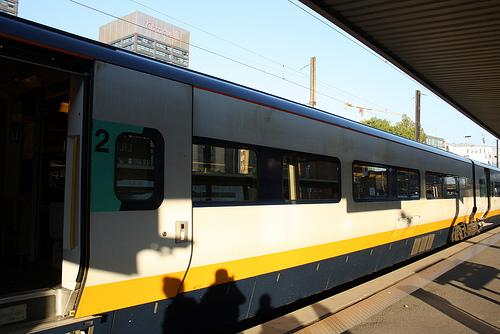What can be seen in the sky in the image? There is a clear blue cloudless sky with telephone wires and a building tower. What is the state of the train door? The train door is open for people to board and get off. What is located above the train? There is an overhang of the train station above the train. List three background features in the image. A wooden telephone pole, trees, and buildings are in the background. Are any objects casting shadows, and if so, on which side of the train? Yes, shadows of people and objects are visible on the side of the train. Briefly describe the ground beside the train. People are casting shadows near a yellow line on the ground. Which line number does the train have? The train is numbered as the 2 train. Can you describe any visible nature in the image? There are trees visible behind the train in the skyline. Identify the main object in the image and its color scheme. A train is the main object with black, yellow, and white color scheme. What are the main colors of the stripes on the train? The stripes on the train are blue and yellow. 